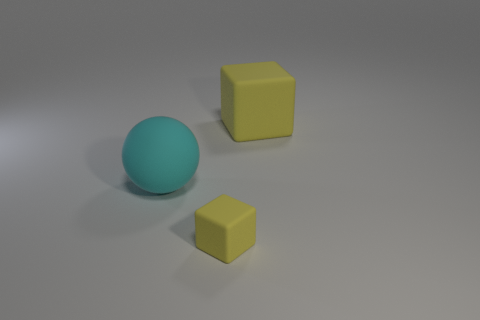There is a matte object that is on the right side of the yellow object that is in front of the ball; what is its shape?
Your answer should be very brief. Cube. Is there any other thing that is the same shape as the big cyan matte object?
Ensure brevity in your answer.  No. There is a big rubber thing right of the matte sphere; is its shape the same as the small yellow rubber thing?
Ensure brevity in your answer.  Yes. There is a cyan thing; what shape is it?
Keep it short and to the point. Sphere. What material is the small cube that is the same color as the big cube?
Your answer should be very brief. Rubber. What number of things are either yellow rubber cubes or gray rubber cylinders?
Your answer should be very brief. 2. Is the material of the yellow object left of the big yellow matte object the same as the sphere?
Give a very brief answer. Yes. How many things are big things that are behind the rubber ball or big yellow matte things?
Your response must be concise. 1. There is another block that is made of the same material as the small yellow block; what color is it?
Give a very brief answer. Yellow. Is there a purple cylinder of the same size as the ball?
Your response must be concise. No. 